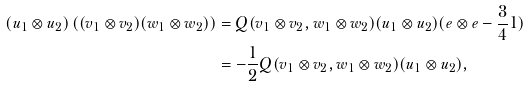Convert formula to latex. <formula><loc_0><loc_0><loc_500><loc_500>( u _ { 1 } \otimes u _ { 2 } ) \left ( ( v _ { 1 } \otimes v _ { 2 } ) ( w _ { 1 } \otimes w _ { 2 } ) \right ) & = Q ( v _ { 1 } \otimes v _ { 2 } , w _ { 1 } \otimes w _ { 2 } ) ( u _ { 1 } \otimes u _ { 2 } ) ( e \otimes e - \frac { 3 } { 4 } 1 ) \\ & = - \frac { 1 } { 2 } Q ( v _ { 1 } \otimes v _ { 2 } , w _ { 1 } \otimes w _ { 2 } ) ( u _ { 1 } \otimes u _ { 2 } ) ,</formula> 